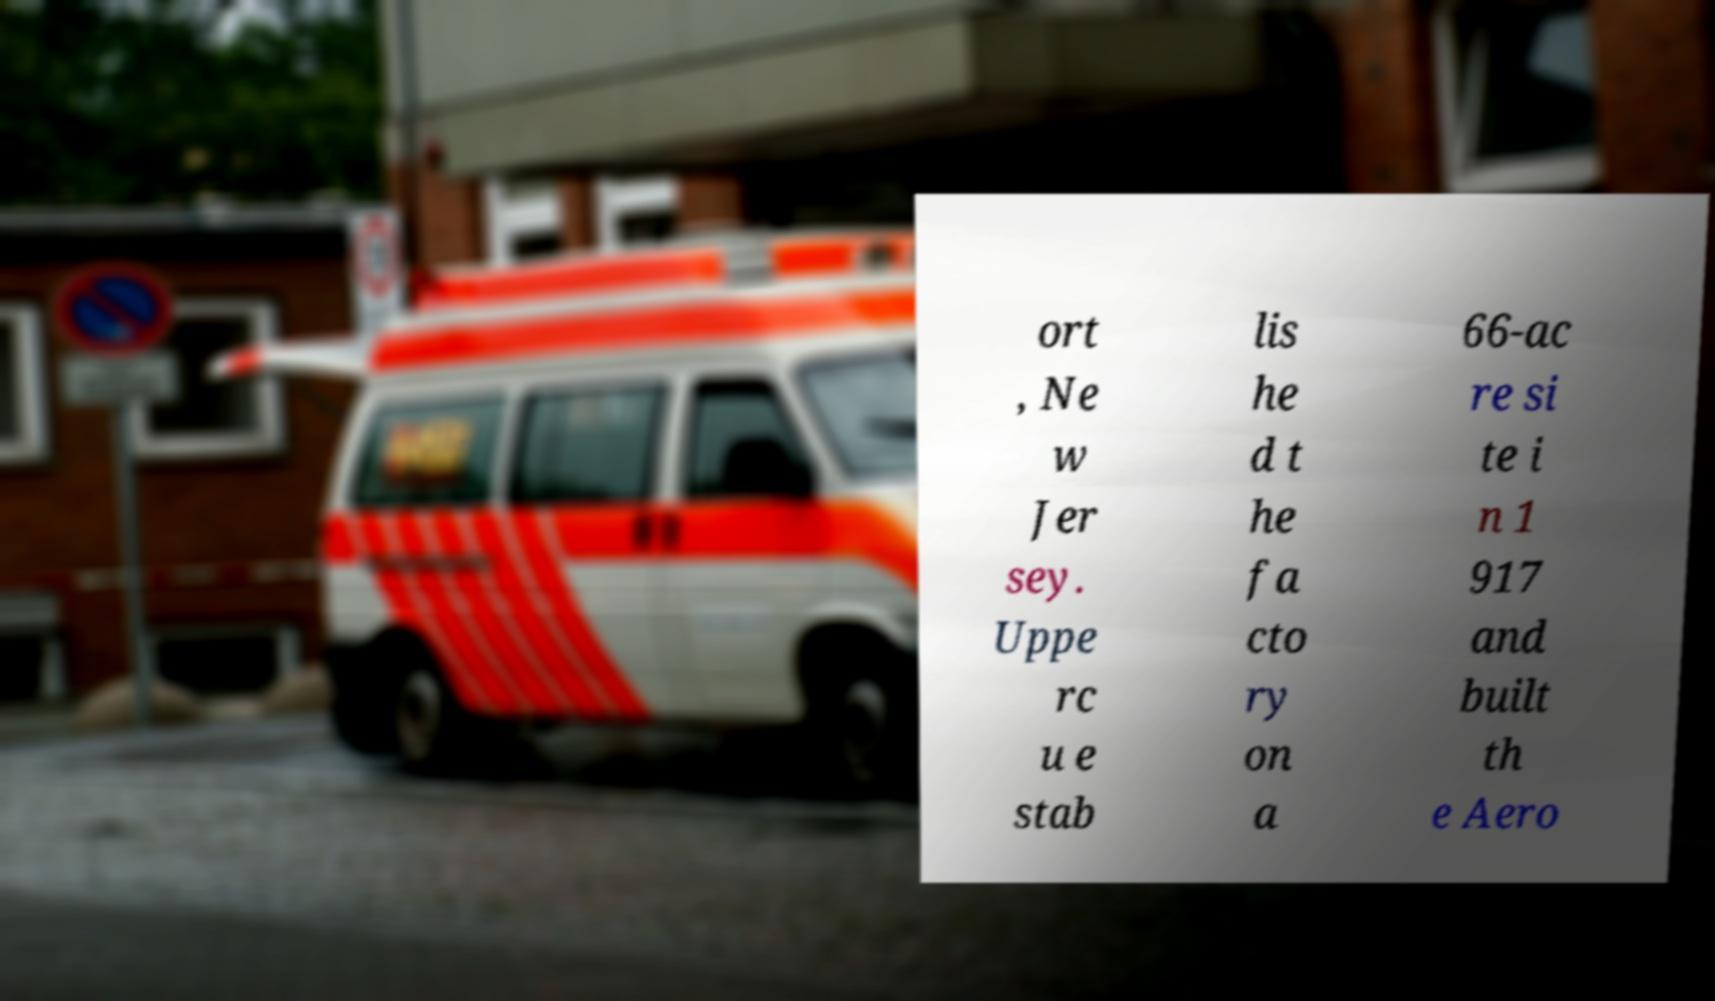I need the written content from this picture converted into text. Can you do that? ort , Ne w Jer sey. Uppe rc u e stab lis he d t he fa cto ry on a 66-ac re si te i n 1 917 and built th e Aero 